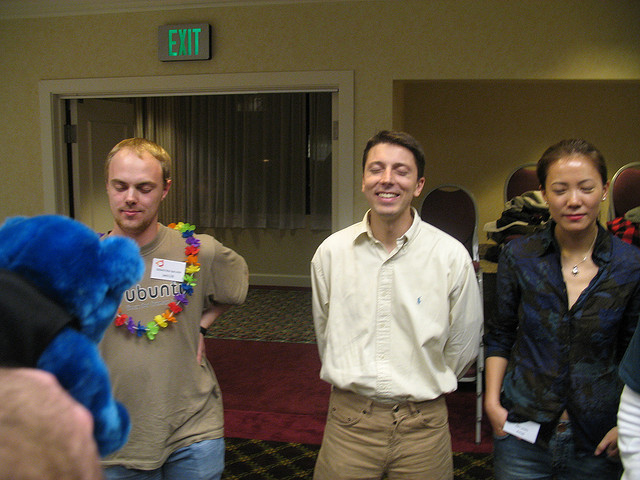Read and extract the text from this image. EXIT ubunti 